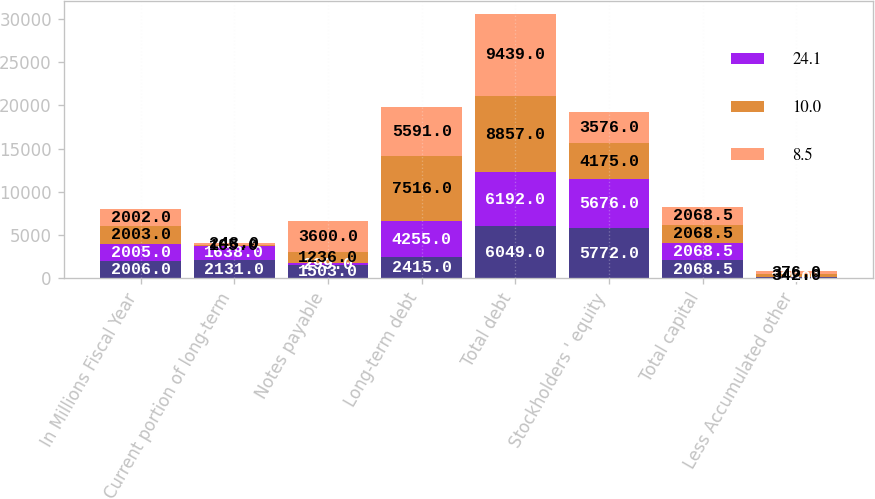Convert chart to OTSL. <chart><loc_0><loc_0><loc_500><loc_500><stacked_bar_chart><ecel><fcel>In Millions Fiscal Year<fcel>Current portion of long-term<fcel>Notes payable<fcel>Long-term debt<fcel>Total debt<fcel>Stockholders ' equity<fcel>Total capital<fcel>Less Accumulated other<nl><fcel>nan<fcel>2006<fcel>2131<fcel>1503<fcel>2415<fcel>6049<fcel>5772<fcel>2068.5<fcel>125<nl><fcel>24.1<fcel>2005<fcel>1638<fcel>299<fcel>4255<fcel>6192<fcel>5676<fcel>2068.5<fcel>8<nl><fcel>10<fcel>2003<fcel>105<fcel>1236<fcel>7516<fcel>8857<fcel>4175<fcel>2068.5<fcel>342<nl><fcel>8.5<fcel>2002<fcel>248<fcel>3600<fcel>5591<fcel>9439<fcel>3576<fcel>2068.5<fcel>376<nl></chart> 